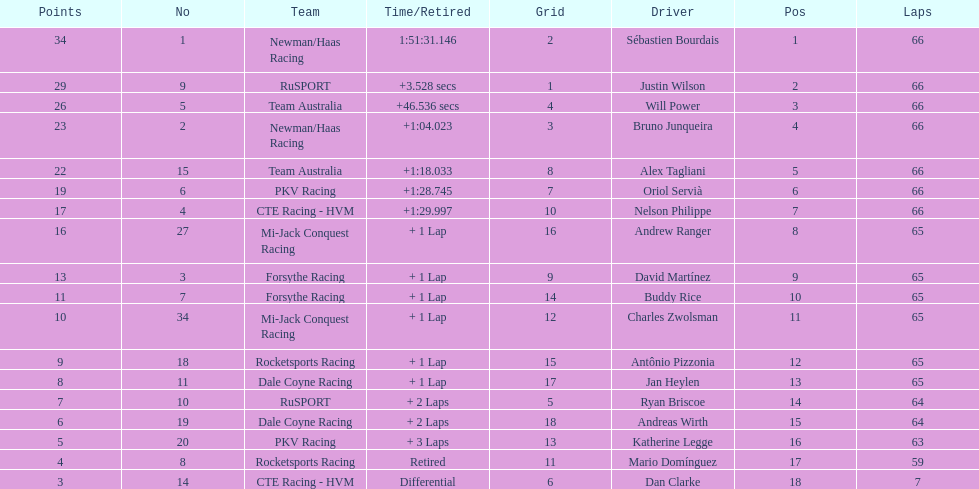Which driver has the same number as his/her position? Sébastien Bourdais. 